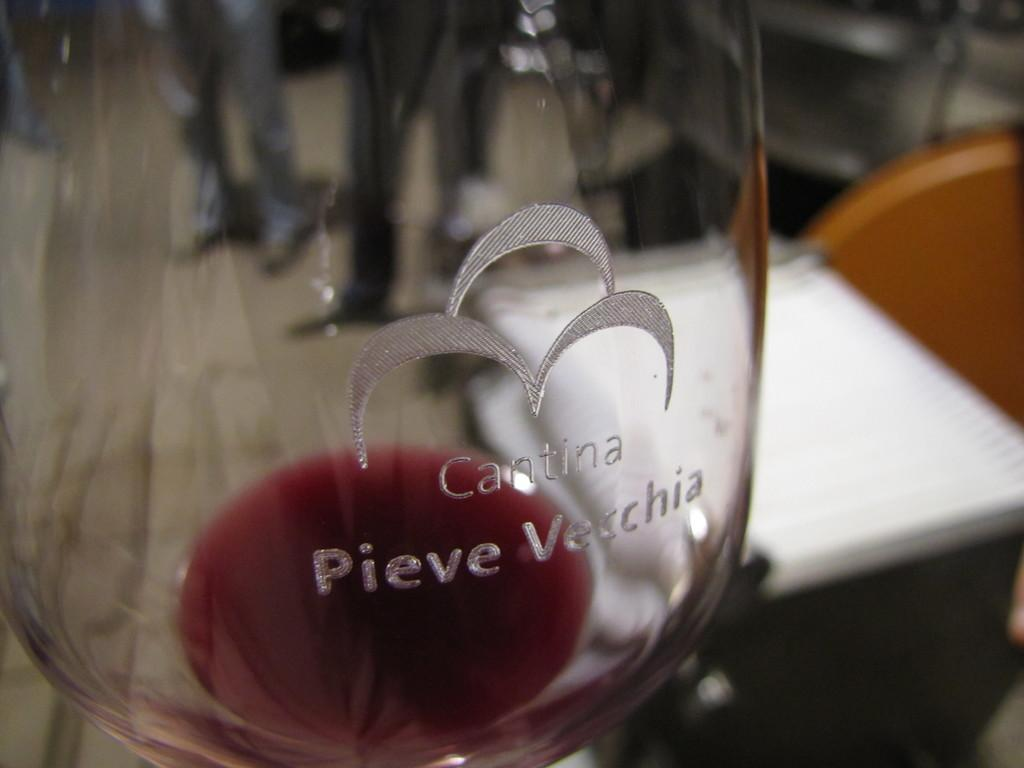Provide a one-sentence caption for the provided image. A Cantina wine glass is almost empty with some wine left at the bottom. 